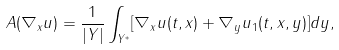<formula> <loc_0><loc_0><loc_500><loc_500>A ( \nabla _ { x } u ) = \frac { 1 } { | Y | } \int _ { Y ^ { * } } [ \nabla _ { x } u ( t , x ) + \nabla _ { y } u _ { 1 } ( t , x , y ) ] d y ,</formula> 